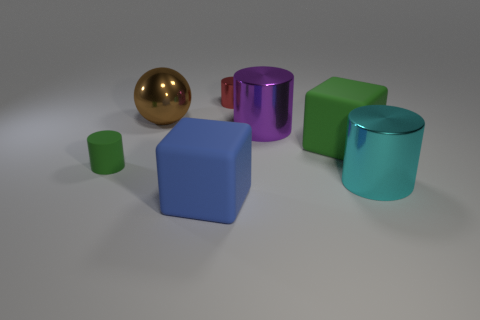Add 2 gray matte objects. How many objects exist? 9 Subtract all blocks. How many objects are left? 5 Add 5 big green matte cubes. How many big green matte cubes are left? 6 Add 3 yellow matte things. How many yellow matte things exist? 3 Subtract 1 green cylinders. How many objects are left? 6 Subtract all tiny matte balls. Subtract all small rubber things. How many objects are left? 6 